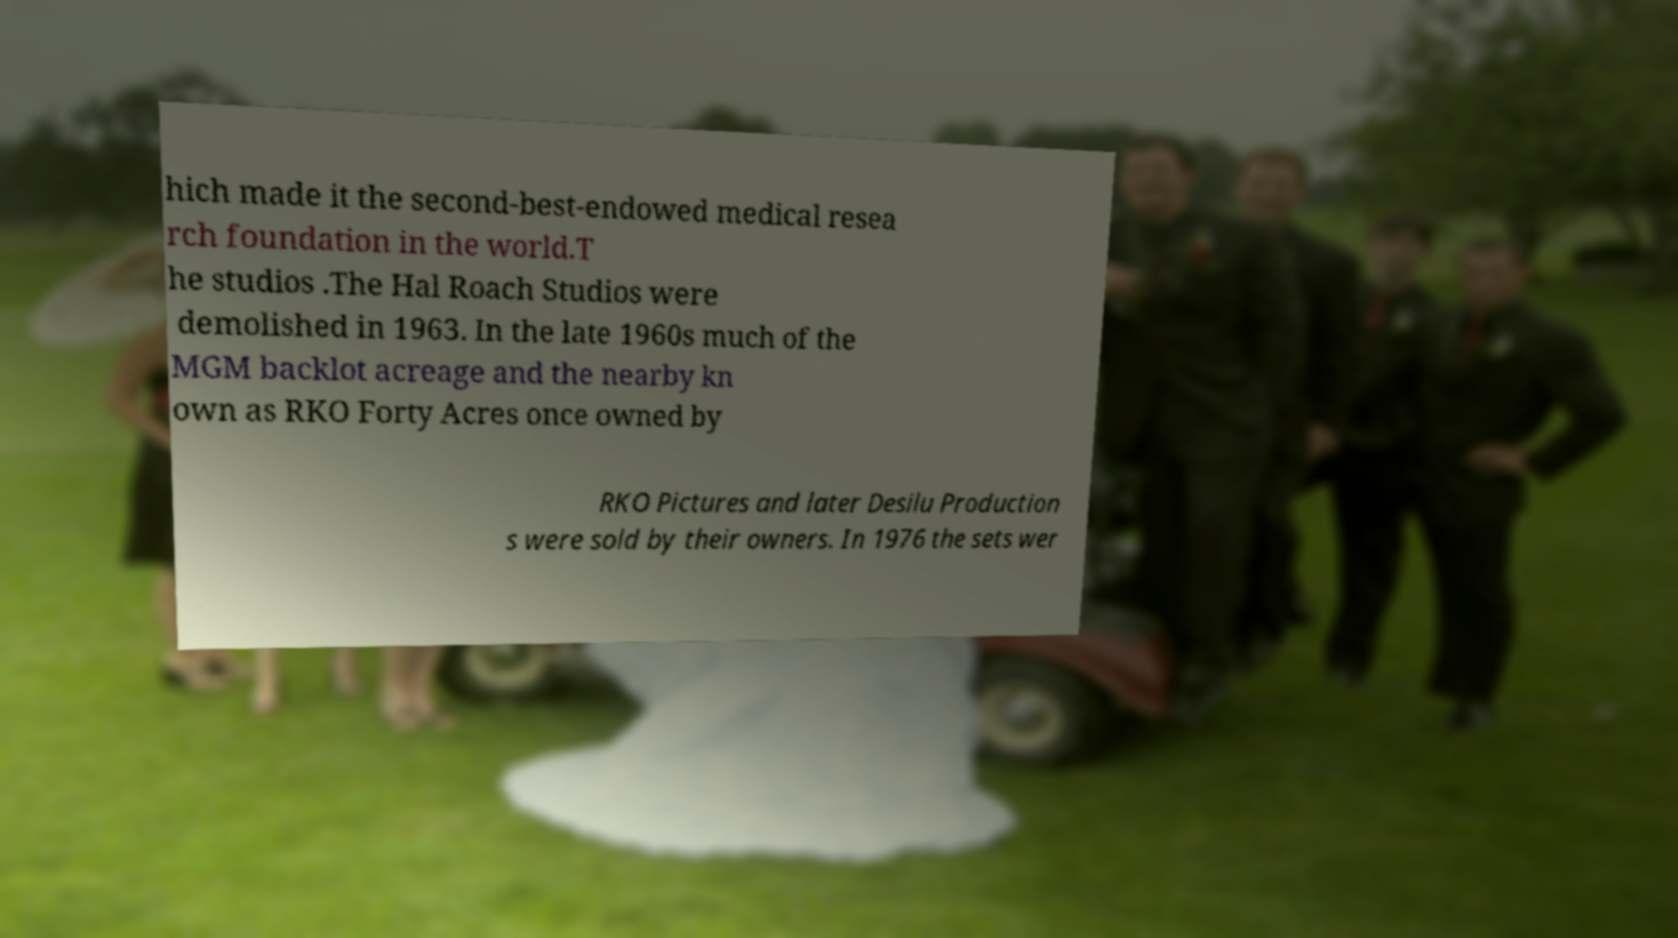Could you assist in decoding the text presented in this image and type it out clearly? hich made it the second-best-endowed medical resea rch foundation in the world.T he studios .The Hal Roach Studios were demolished in 1963. In the late 1960s much of the MGM backlot acreage and the nearby kn own as RKO Forty Acres once owned by RKO Pictures and later Desilu Production s were sold by their owners. In 1976 the sets wer 